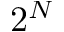Convert formula to latex. <formula><loc_0><loc_0><loc_500><loc_500>2 ^ { N }</formula> 